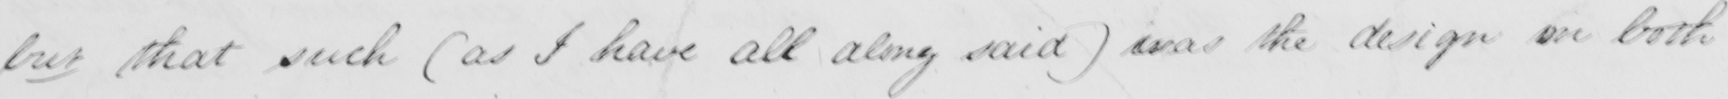Transcribe the text shown in this historical manuscript line. but that such  ( as I have all along said  )  was the design on both 